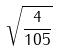Convert formula to latex. <formula><loc_0><loc_0><loc_500><loc_500>\sqrt { \frac { 4 } { 1 0 5 } }</formula> 